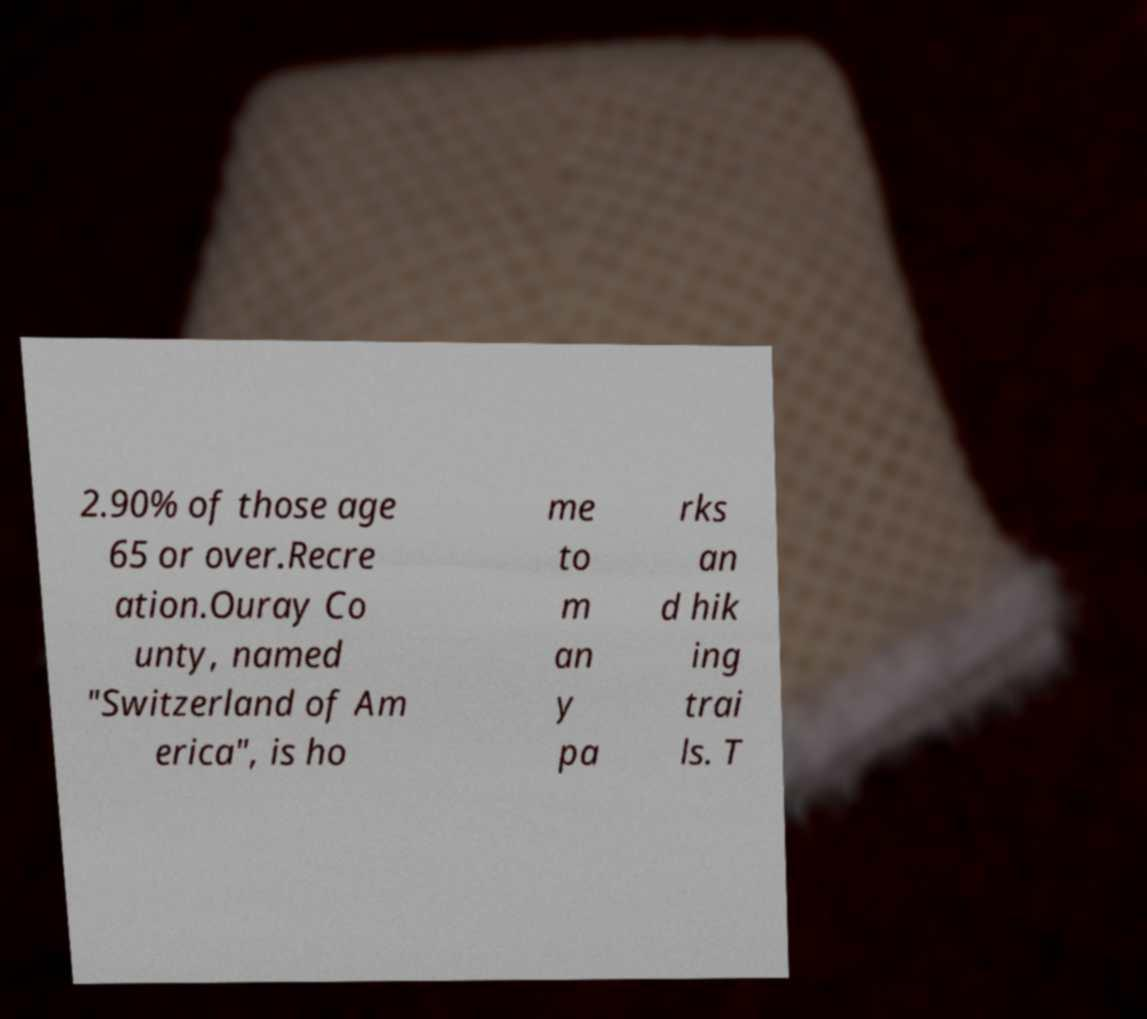Can you read and provide the text displayed in the image?This photo seems to have some interesting text. Can you extract and type it out for me? 2.90% of those age 65 or over.Recre ation.Ouray Co unty, named "Switzerland of Am erica", is ho me to m an y pa rks an d hik ing trai ls. T 